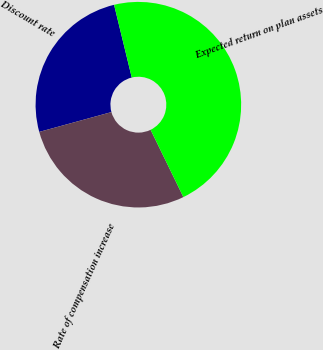Convert chart. <chart><loc_0><loc_0><loc_500><loc_500><pie_chart><fcel>Discount rate<fcel>Rate of compensation increase<fcel>Expected return on plan assets<nl><fcel>25.47%<fcel>27.95%<fcel>46.58%<nl></chart> 